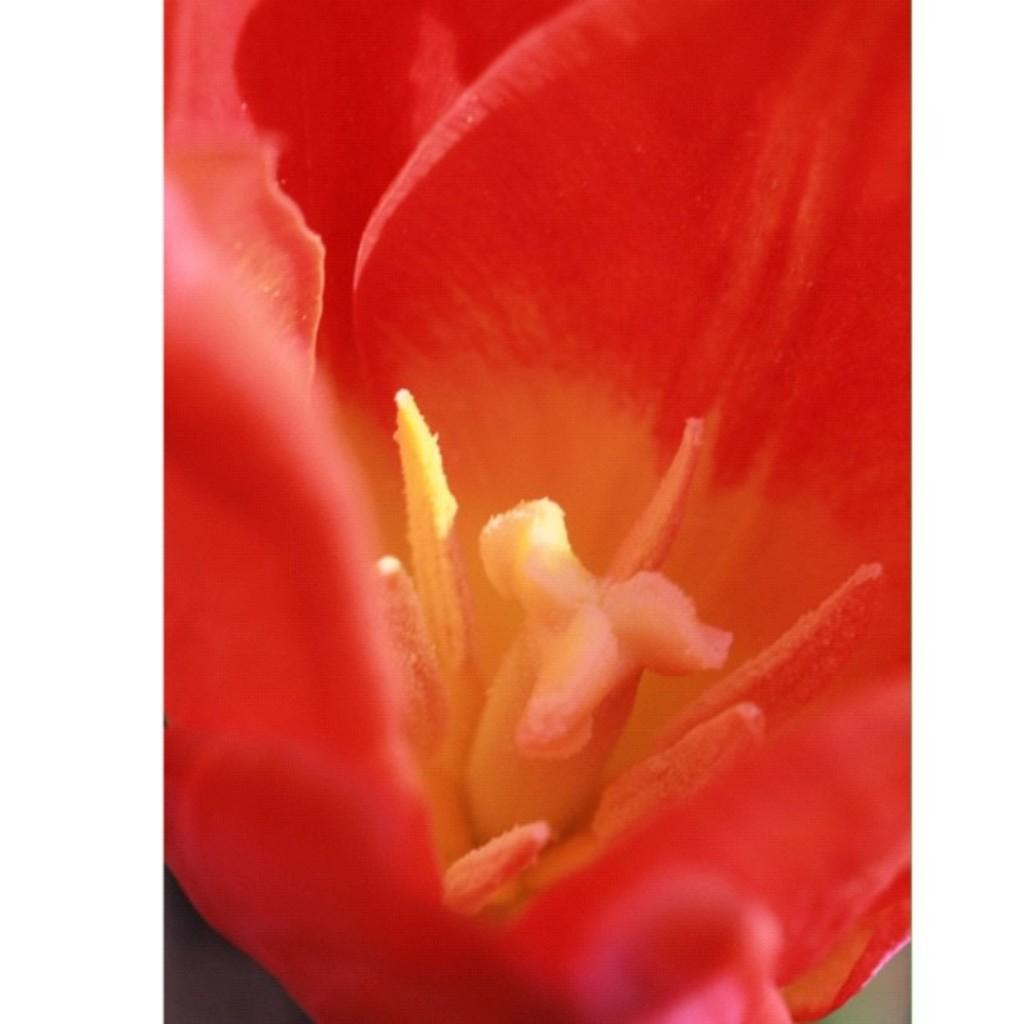What type of flower is present in the image? There is a red flower in the image. Can you describe the object in the middle of the flower? Unfortunately, the facts provided do not give any information about the object in the middle of the flower. How many yaks are visible in the image? There are no yaks present in the image. What type of worm can be seen crawling on the flower in the image? There is no worm visible in the image. 